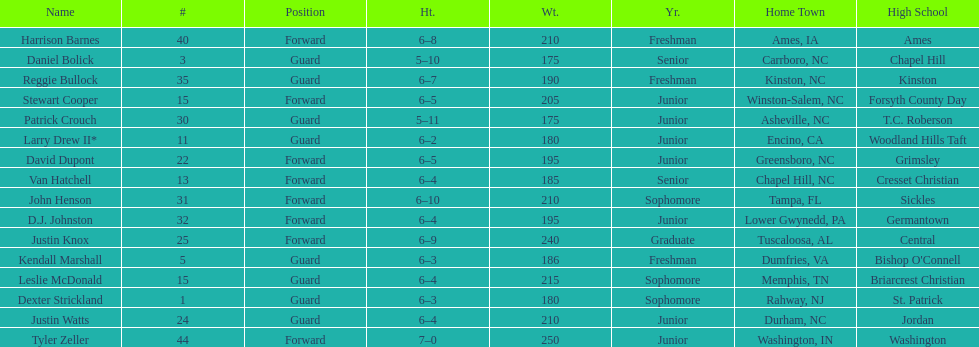What is the number of players with a weight over 200? 7. 